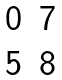<formula> <loc_0><loc_0><loc_500><loc_500>\begin{matrix} 0 & 7 \\ 5 & 8 \end{matrix}</formula> 